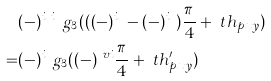Convert formula to latex. <formula><loc_0><loc_0><loc_500><loc_500>& ( - ) ^ { i _ { x } i _ { y } } g _ { 3 } ( ( ( - ) ^ { i _ { y } } - ( - ) ^ { i _ { x } } ) \frac { \pi } { 4 } + \ t h _ { p x y } ) \\ = & ( - ) ^ { i _ { x } } g _ { 3 } ( ( - ) ^ { \ v i } \frac { \pi } { 4 } + \ t h _ { p x y } ^ { \prime } )</formula> 